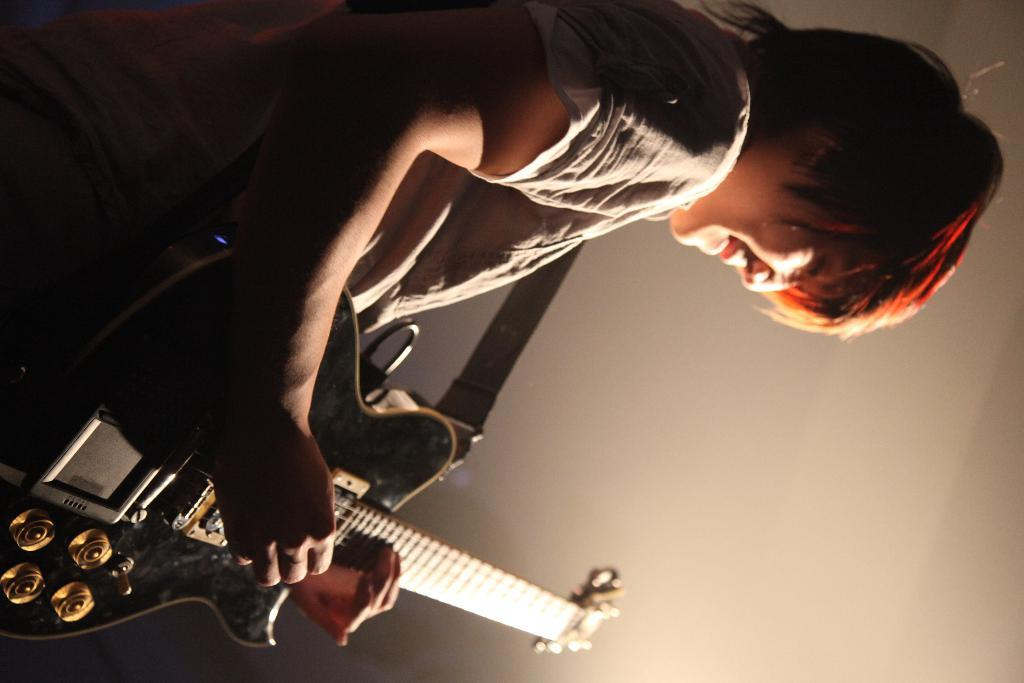What is the main subject of the image? The main subject of the image is a man. What is the man holding in the image? The man is holding a guitar. What type of ice can be seen melting on the guitar in the image? There is no ice present in the image, and the guitar is not associated with any ice. 